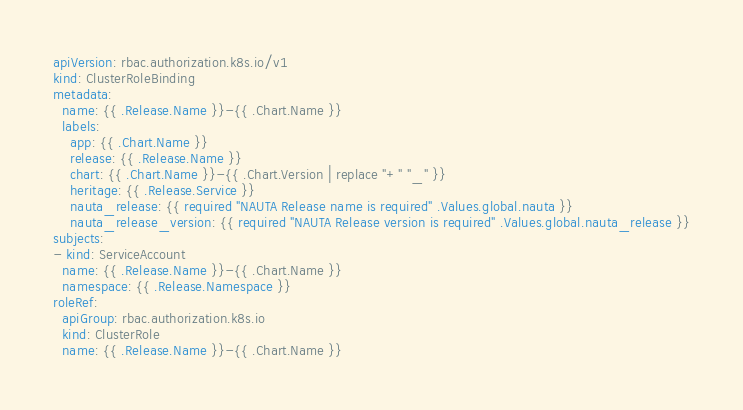Convert code to text. <code><loc_0><loc_0><loc_500><loc_500><_YAML_>apiVersion: rbac.authorization.k8s.io/v1
kind: ClusterRoleBinding
metadata:
  name: {{ .Release.Name }}-{{ .Chart.Name }}
  labels:
    app: {{ .Chart.Name }}
    release: {{ .Release.Name }}
    chart: {{ .Chart.Name }}-{{ .Chart.Version | replace "+" "_" }}
    heritage: {{ .Release.Service }}
    nauta_release: {{ required "NAUTA Release name is required" .Values.global.nauta }}
    nauta_release_version: {{ required "NAUTA Release version is required" .Values.global.nauta_release }}
subjects:
- kind: ServiceAccount
  name: {{ .Release.Name }}-{{ .Chart.Name }}
  namespace: {{ .Release.Namespace }}
roleRef:
  apiGroup: rbac.authorization.k8s.io
  kind: ClusterRole
  name: {{ .Release.Name }}-{{ .Chart.Name }}
</code> 